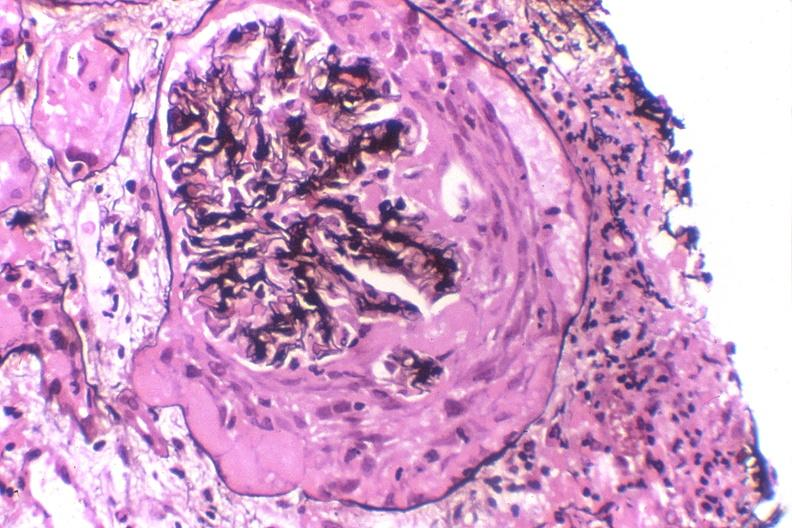what stain?
Answer the question using a single word or phrase. Silver 